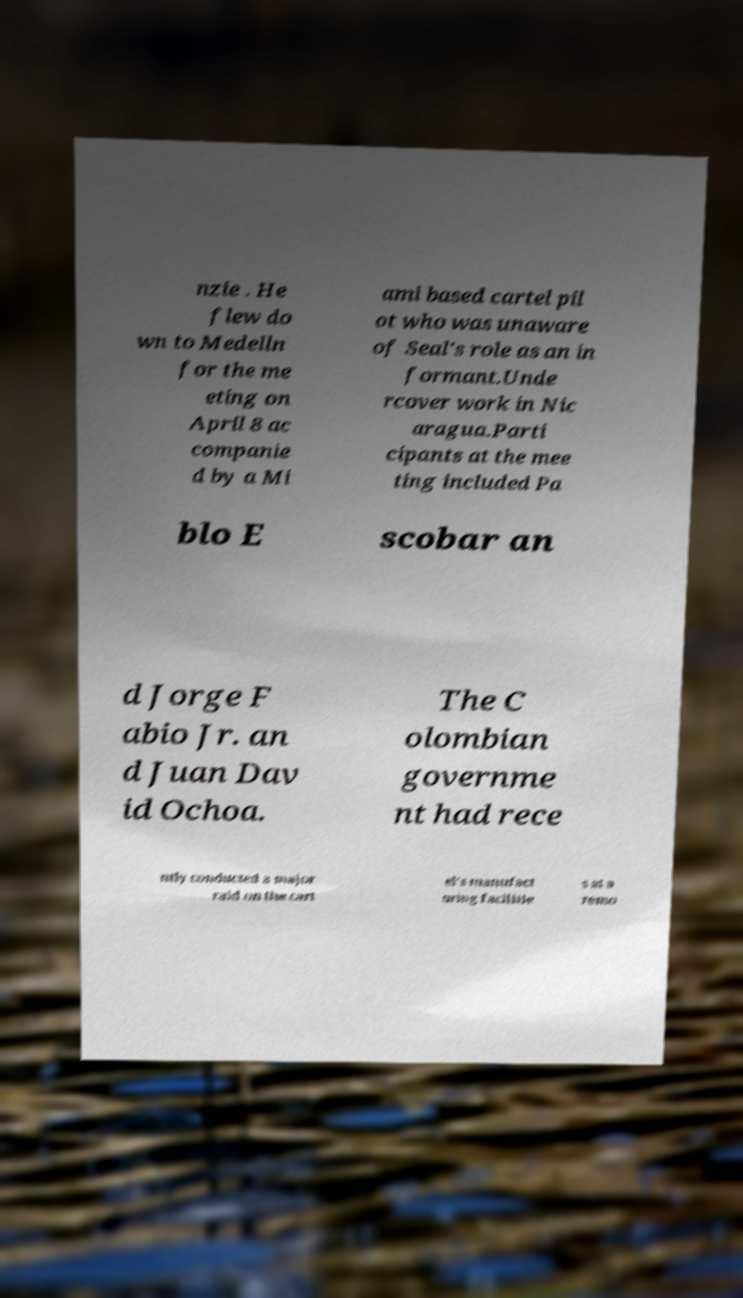There's text embedded in this image that I need extracted. Can you transcribe it verbatim? nzie . He flew do wn to Medelln for the me eting on April 8 ac companie d by a Mi ami based cartel pil ot who was unaware of Seal's role as an in formant.Unde rcover work in Nic aragua.Parti cipants at the mee ting included Pa blo E scobar an d Jorge F abio Jr. an d Juan Dav id Ochoa. The C olombian governme nt had rece ntly conducted a major raid on the cart el's manufact uring facilitie s at a remo 